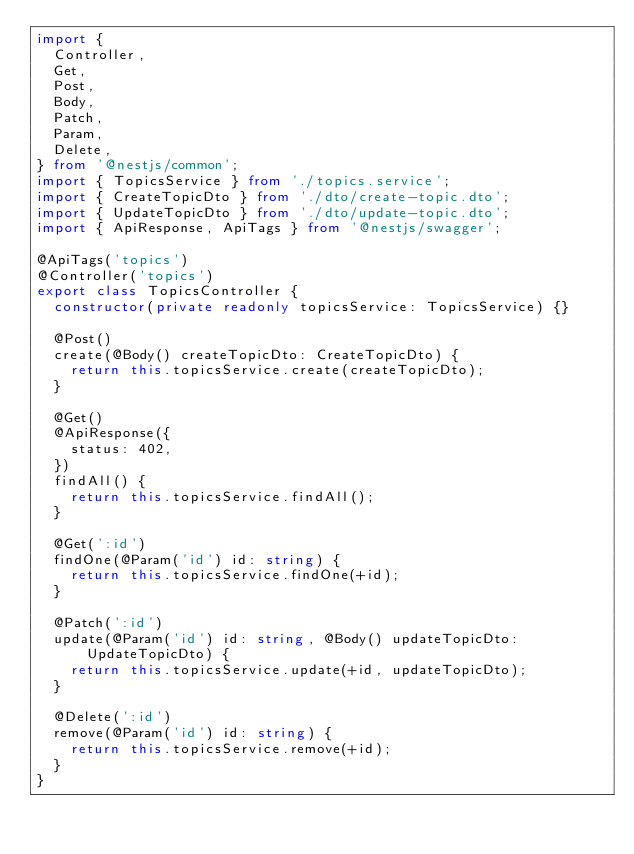Convert code to text. <code><loc_0><loc_0><loc_500><loc_500><_TypeScript_>import {
  Controller,
  Get,
  Post,
  Body,
  Patch,
  Param,
  Delete,
} from '@nestjs/common';
import { TopicsService } from './topics.service';
import { CreateTopicDto } from './dto/create-topic.dto';
import { UpdateTopicDto } from './dto/update-topic.dto';
import { ApiResponse, ApiTags } from '@nestjs/swagger';

@ApiTags('topics')
@Controller('topics')
export class TopicsController {
  constructor(private readonly topicsService: TopicsService) {}

  @Post()
  create(@Body() createTopicDto: CreateTopicDto) {
    return this.topicsService.create(createTopicDto);
  }

  @Get()
  @ApiResponse({
    status: 402,
  })
  findAll() {
    return this.topicsService.findAll();
  }

  @Get(':id')
  findOne(@Param('id') id: string) {
    return this.topicsService.findOne(+id);
  }

  @Patch(':id')
  update(@Param('id') id: string, @Body() updateTopicDto: UpdateTopicDto) {
    return this.topicsService.update(+id, updateTopicDto);
  }

  @Delete(':id')
  remove(@Param('id') id: string) {
    return this.topicsService.remove(+id);
  }
}
</code> 